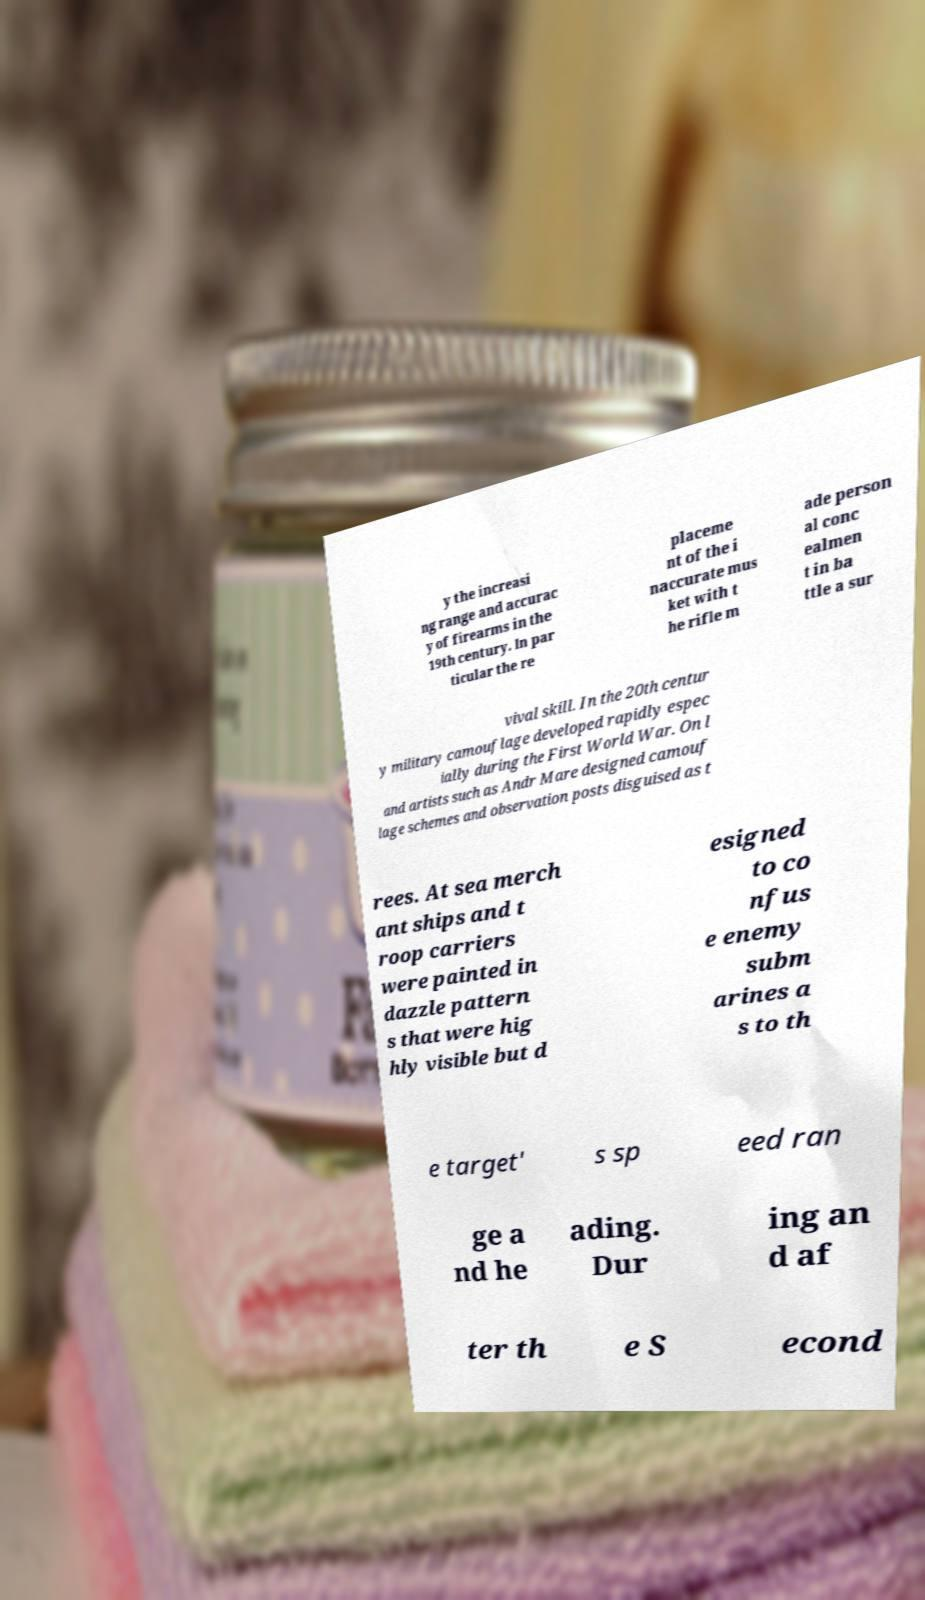Could you assist in decoding the text presented in this image and type it out clearly? y the increasi ng range and accurac y of firearms in the 19th century. In par ticular the re placeme nt of the i naccurate mus ket with t he rifle m ade person al conc ealmen t in ba ttle a sur vival skill. In the 20th centur y military camouflage developed rapidly espec ially during the First World War. On l and artists such as Andr Mare designed camouf lage schemes and observation posts disguised as t rees. At sea merch ant ships and t roop carriers were painted in dazzle pattern s that were hig hly visible but d esigned to co nfus e enemy subm arines a s to th e target' s sp eed ran ge a nd he ading. Dur ing an d af ter th e S econd 